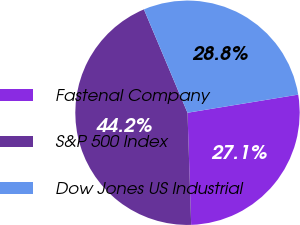Convert chart. <chart><loc_0><loc_0><loc_500><loc_500><pie_chart><fcel>Fastenal Company<fcel>S&P 500 Index<fcel>Dow Jones US Industrial<nl><fcel>27.06%<fcel>44.17%<fcel>28.77%<nl></chart> 